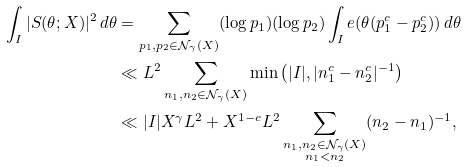<formula> <loc_0><loc_0><loc_500><loc_500>\int _ { I } | S ( \theta ; X ) | ^ { 2 } \, d \theta & = \sum _ { p _ { 1 } , p _ { 2 } \in \mathcal { N } _ { \gamma } ( X ) } ( \log p _ { 1 } ) ( \log p _ { 2 } ) \int _ { I } e ( \theta ( p _ { 1 } ^ { c } - p _ { 2 } ^ { c } ) ) \, d \theta \\ & \ll L ^ { 2 } \sum _ { n _ { 1 } , n _ { 2 } \in \mathcal { N } _ { \gamma } ( X ) } \min \left ( | I | , | n _ { 1 } ^ { c } - n _ { 2 } ^ { c } | ^ { - 1 } \right ) \\ & \ll | I | X ^ { \gamma } L ^ { 2 } + X ^ { 1 - c } L ^ { 2 } \sum _ { \substack { n _ { 1 } , n _ { 2 } \in \mathcal { N } _ { \gamma } ( X ) \\ n _ { 1 } < n _ { 2 } } } ( n _ { 2 } - n _ { 1 } ) ^ { - 1 } ,</formula> 